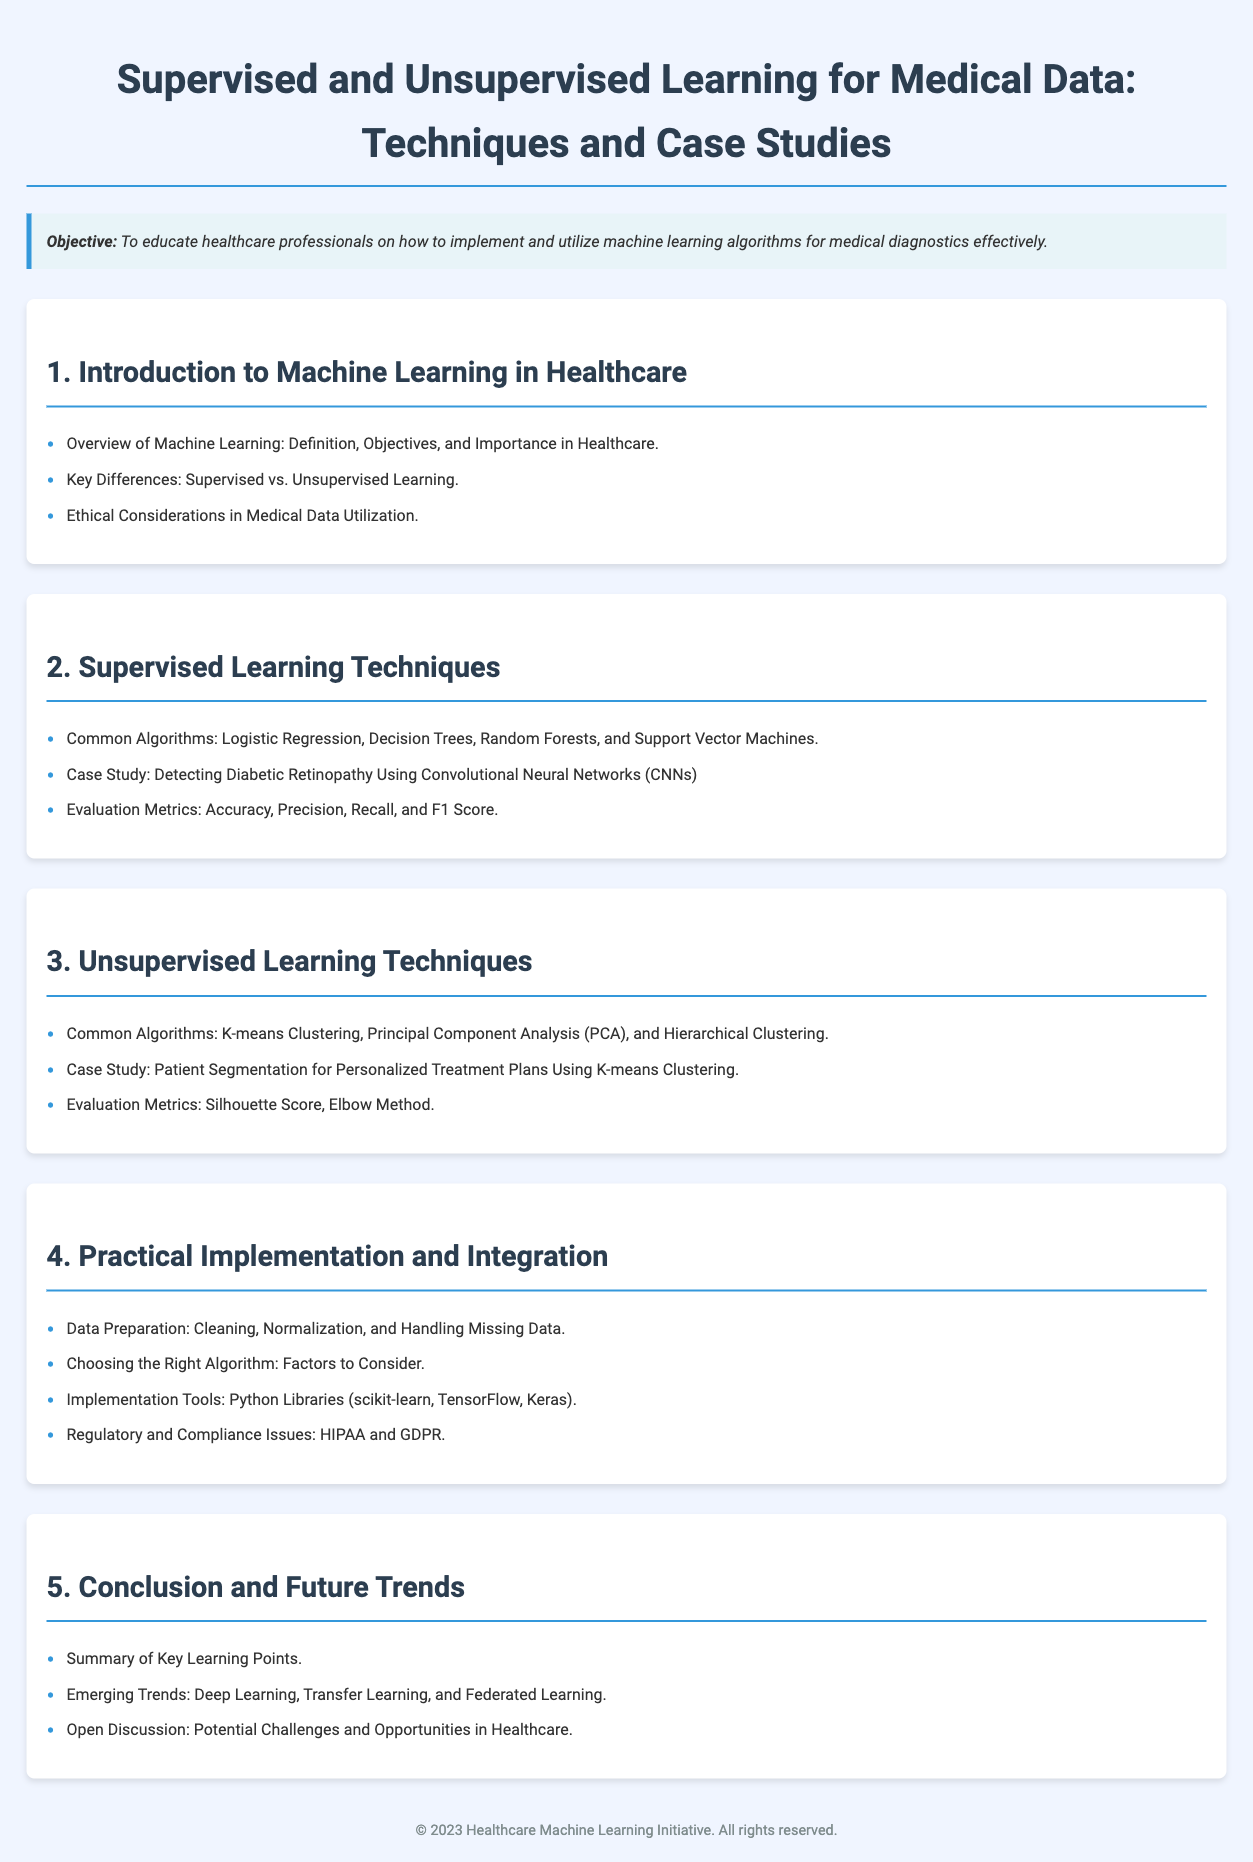what is the title of the lesson plan? The title of the lesson plan is clearly stated at the top of the document and describes its focus on supervised and unsupervised learning in healthcare.
Answer: Supervised and Unsupervised Learning for Medical Data: Techniques and Case Studies what is the primary objective of the lesson plan? The objective is outlined in the designated objective section, summarizing the intent of the lesson plan.
Answer: To educate healthcare professionals on how to implement and utilize machine learning algorithms for medical diagnostics effectively which section covers supervised learning techniques? The section specifically focused on supervised learning and its techniques is detailed under one of the major headings in the document.
Answer: 2. Supervised Learning Techniques name one common algorithm listed under unsupervised learning techniques. The document lists specific algorithms utilized in unsupervised learning within a dedicated section describing them.
Answer: K-means Clustering what evaluation metric is mentioned for supervised learning? The document identifies a set of evaluation metrics that are important for assessing supervised learning performance.
Answer: Accuracy which tool is suggested for implementation? The implementation tools for machine learning in healthcare are discussed, including various specific libraries.
Answer: Python Libraries (scikit-learn, TensorFlow, Keras) what is one emerging trend mentioned in the conclusion? The trends in the conclusion highlight forward-looking technologies in the field of machine learning and healthcare.
Answer: Deep Learning how many case studies are presented in the document? A careful count of the case studies listed in sections dedicated to supervised and unsupervised learning shows the total number.
Answer: 2 